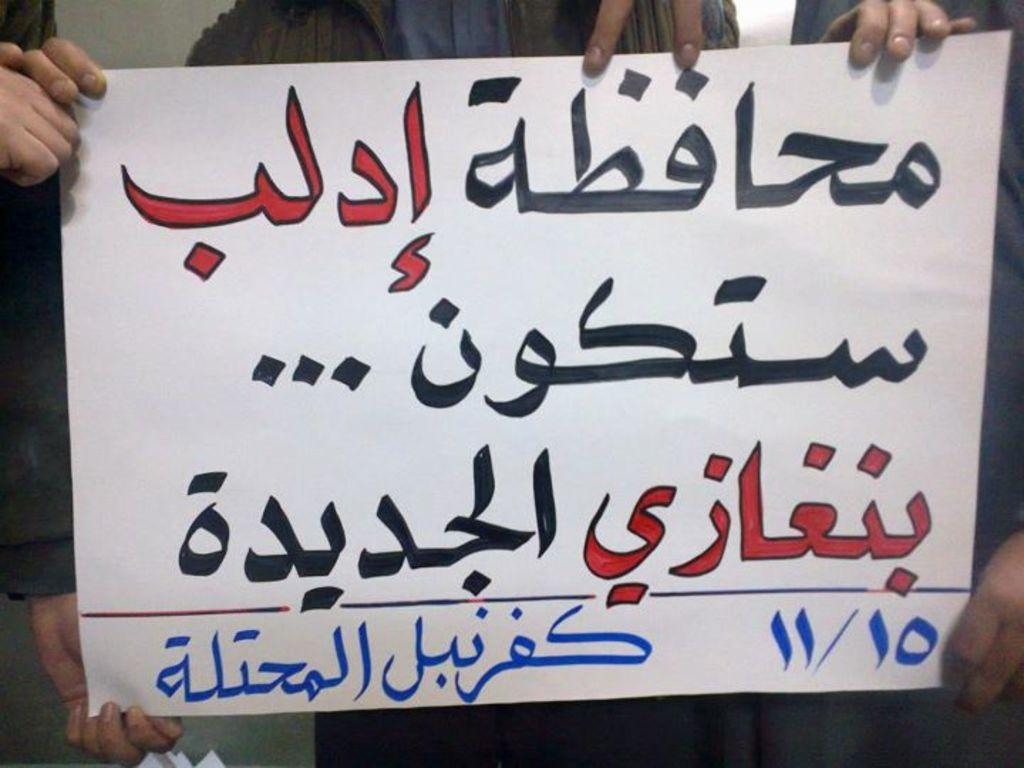What language is written on the paper in the image? The paper in the image has Urdu letters written on it. Can you describe the people in the background of the image? The people in the background of the image are holding the paper. What type of roof can be seen in the image? There is no roof visible in the image. How does the breath of the people holding the paper affect the Urdu letters? The image does not show any breath or its effect on the Urdu letters. 